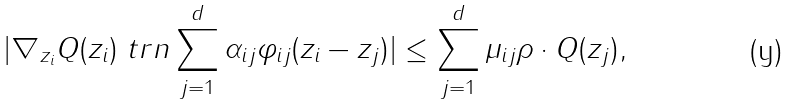Convert formula to latex. <formula><loc_0><loc_0><loc_500><loc_500>| \nabla _ { z _ { i } } Q ( z _ { i } ) \ t r n \sum _ { j = 1 } ^ { d } \alpha _ { i j } \varphi _ { i j } ( z _ { i } - z _ { j } ) | \leq \sum _ { j = 1 } ^ { d } \mu _ { i j } \rho \cdot Q ( z _ { j } ) ,</formula> 